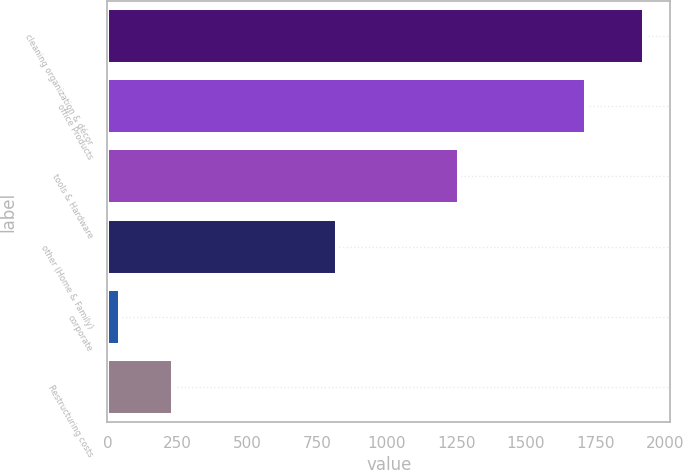<chart> <loc_0><loc_0><loc_500><loc_500><bar_chart><fcel>cleaning organization & décor<fcel>office Products<fcel>tools & Hardware<fcel>other (Home & Family)<fcel>corporate<fcel>Restructuring costs<nl><fcel>1921<fcel>1713.3<fcel>1260.3<fcel>822.6<fcel>46<fcel>233.5<nl></chart> 